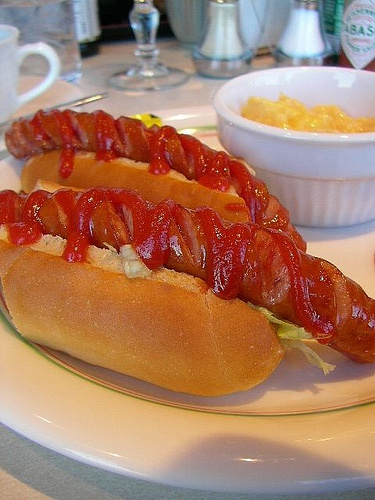Describe the objects in this image and their specific colors. I can see dining table in red, darkgray, maroon, tan, and lightgray tones, hot dog in gray, red, and maroon tones, bowl in gray, darkgray, lavender, and orange tones, hot dog in gray, brown, and maroon tones, and cup in gray, darkgray, and lightgray tones in this image. 